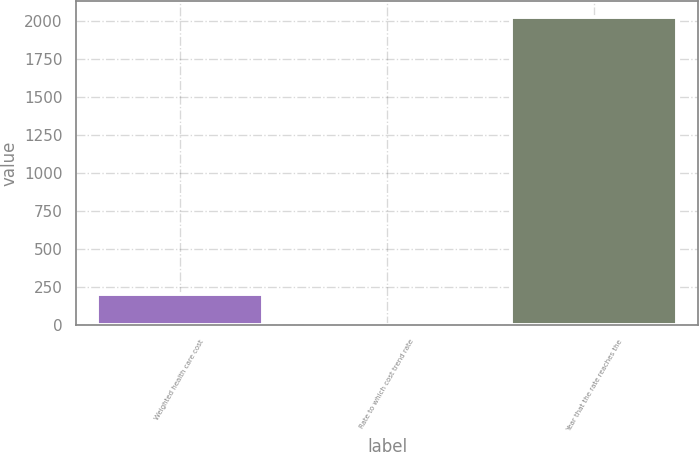Convert chart. <chart><loc_0><loc_0><loc_500><loc_500><bar_chart><fcel>Weighted health care cost<fcel>Rate to which cost trend rate<fcel>Year that the rate reaches the<nl><fcel>206.95<fcel>4.5<fcel>2029<nl></chart> 